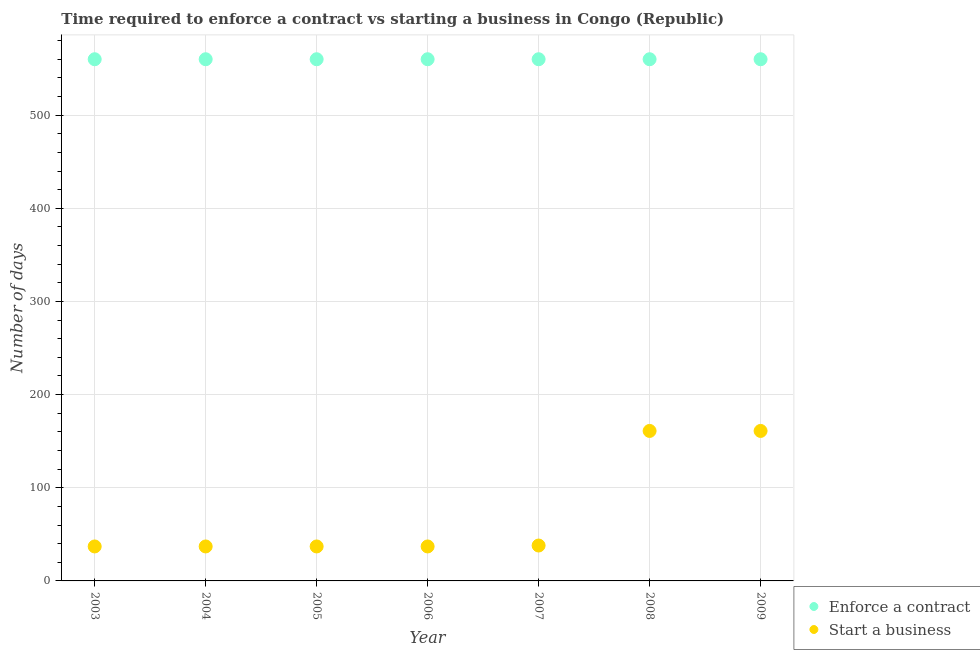What is the number of days to start a business in 2006?
Give a very brief answer. 37. Across all years, what is the maximum number of days to enforece a contract?
Provide a succinct answer. 560. Across all years, what is the minimum number of days to enforece a contract?
Provide a succinct answer. 560. In which year was the number of days to enforece a contract maximum?
Keep it short and to the point. 2003. What is the total number of days to start a business in the graph?
Offer a terse response. 508. What is the difference between the number of days to start a business in 2003 and that in 2009?
Ensure brevity in your answer.  -124. What is the difference between the number of days to enforece a contract in 2003 and the number of days to start a business in 2006?
Offer a terse response. 523. What is the average number of days to enforece a contract per year?
Provide a succinct answer. 560. In the year 2004, what is the difference between the number of days to enforece a contract and number of days to start a business?
Offer a terse response. 523. What is the ratio of the number of days to start a business in 2004 to that in 2007?
Offer a terse response. 0.97. Is the difference between the number of days to enforece a contract in 2005 and 2008 greater than the difference between the number of days to start a business in 2005 and 2008?
Give a very brief answer. Yes. What is the difference between the highest and the lowest number of days to start a business?
Provide a succinct answer. 124. How many years are there in the graph?
Your response must be concise. 7. What is the difference between two consecutive major ticks on the Y-axis?
Make the answer very short. 100. Does the graph contain any zero values?
Your response must be concise. No. Where does the legend appear in the graph?
Your answer should be very brief. Bottom right. What is the title of the graph?
Provide a succinct answer. Time required to enforce a contract vs starting a business in Congo (Republic). What is the label or title of the X-axis?
Make the answer very short. Year. What is the label or title of the Y-axis?
Provide a succinct answer. Number of days. What is the Number of days in Enforce a contract in 2003?
Provide a short and direct response. 560. What is the Number of days in Start a business in 2003?
Give a very brief answer. 37. What is the Number of days in Enforce a contract in 2004?
Keep it short and to the point. 560. What is the Number of days in Enforce a contract in 2005?
Your response must be concise. 560. What is the Number of days of Enforce a contract in 2006?
Ensure brevity in your answer.  560. What is the Number of days in Start a business in 2006?
Offer a very short reply. 37. What is the Number of days of Enforce a contract in 2007?
Your answer should be compact. 560. What is the Number of days in Start a business in 2007?
Ensure brevity in your answer.  38. What is the Number of days in Enforce a contract in 2008?
Your answer should be very brief. 560. What is the Number of days in Start a business in 2008?
Give a very brief answer. 161. What is the Number of days in Enforce a contract in 2009?
Ensure brevity in your answer.  560. What is the Number of days of Start a business in 2009?
Ensure brevity in your answer.  161. Across all years, what is the maximum Number of days in Enforce a contract?
Keep it short and to the point. 560. Across all years, what is the maximum Number of days of Start a business?
Offer a very short reply. 161. Across all years, what is the minimum Number of days of Enforce a contract?
Your answer should be compact. 560. What is the total Number of days in Enforce a contract in the graph?
Offer a terse response. 3920. What is the total Number of days of Start a business in the graph?
Offer a terse response. 508. What is the difference between the Number of days of Enforce a contract in 2003 and that in 2004?
Offer a terse response. 0. What is the difference between the Number of days in Start a business in 2003 and that in 2005?
Give a very brief answer. 0. What is the difference between the Number of days of Enforce a contract in 2003 and that in 2006?
Ensure brevity in your answer.  0. What is the difference between the Number of days in Enforce a contract in 2003 and that in 2007?
Your answer should be very brief. 0. What is the difference between the Number of days of Start a business in 2003 and that in 2007?
Your response must be concise. -1. What is the difference between the Number of days in Start a business in 2003 and that in 2008?
Provide a short and direct response. -124. What is the difference between the Number of days in Enforce a contract in 2003 and that in 2009?
Offer a terse response. 0. What is the difference between the Number of days in Start a business in 2003 and that in 2009?
Keep it short and to the point. -124. What is the difference between the Number of days of Enforce a contract in 2004 and that in 2005?
Offer a very short reply. 0. What is the difference between the Number of days in Enforce a contract in 2004 and that in 2006?
Give a very brief answer. 0. What is the difference between the Number of days in Start a business in 2004 and that in 2006?
Keep it short and to the point. 0. What is the difference between the Number of days in Start a business in 2004 and that in 2007?
Your response must be concise. -1. What is the difference between the Number of days of Enforce a contract in 2004 and that in 2008?
Your response must be concise. 0. What is the difference between the Number of days in Start a business in 2004 and that in 2008?
Keep it short and to the point. -124. What is the difference between the Number of days of Enforce a contract in 2004 and that in 2009?
Provide a succinct answer. 0. What is the difference between the Number of days of Start a business in 2004 and that in 2009?
Your response must be concise. -124. What is the difference between the Number of days of Enforce a contract in 2005 and that in 2006?
Ensure brevity in your answer.  0. What is the difference between the Number of days of Start a business in 2005 and that in 2006?
Provide a succinct answer. 0. What is the difference between the Number of days of Enforce a contract in 2005 and that in 2007?
Give a very brief answer. 0. What is the difference between the Number of days in Start a business in 2005 and that in 2007?
Ensure brevity in your answer.  -1. What is the difference between the Number of days in Start a business in 2005 and that in 2008?
Keep it short and to the point. -124. What is the difference between the Number of days in Enforce a contract in 2005 and that in 2009?
Offer a terse response. 0. What is the difference between the Number of days in Start a business in 2005 and that in 2009?
Provide a succinct answer. -124. What is the difference between the Number of days in Start a business in 2006 and that in 2008?
Keep it short and to the point. -124. What is the difference between the Number of days of Start a business in 2006 and that in 2009?
Provide a short and direct response. -124. What is the difference between the Number of days of Enforce a contract in 2007 and that in 2008?
Make the answer very short. 0. What is the difference between the Number of days of Start a business in 2007 and that in 2008?
Your answer should be compact. -123. What is the difference between the Number of days of Start a business in 2007 and that in 2009?
Give a very brief answer. -123. What is the difference between the Number of days in Enforce a contract in 2008 and that in 2009?
Make the answer very short. 0. What is the difference between the Number of days of Start a business in 2008 and that in 2009?
Your answer should be very brief. 0. What is the difference between the Number of days in Enforce a contract in 2003 and the Number of days in Start a business in 2004?
Make the answer very short. 523. What is the difference between the Number of days in Enforce a contract in 2003 and the Number of days in Start a business in 2005?
Make the answer very short. 523. What is the difference between the Number of days of Enforce a contract in 2003 and the Number of days of Start a business in 2006?
Your answer should be compact. 523. What is the difference between the Number of days in Enforce a contract in 2003 and the Number of days in Start a business in 2007?
Your answer should be very brief. 522. What is the difference between the Number of days of Enforce a contract in 2003 and the Number of days of Start a business in 2008?
Your answer should be very brief. 399. What is the difference between the Number of days of Enforce a contract in 2003 and the Number of days of Start a business in 2009?
Your answer should be compact. 399. What is the difference between the Number of days of Enforce a contract in 2004 and the Number of days of Start a business in 2005?
Offer a terse response. 523. What is the difference between the Number of days in Enforce a contract in 2004 and the Number of days in Start a business in 2006?
Give a very brief answer. 523. What is the difference between the Number of days of Enforce a contract in 2004 and the Number of days of Start a business in 2007?
Provide a succinct answer. 522. What is the difference between the Number of days in Enforce a contract in 2004 and the Number of days in Start a business in 2008?
Your answer should be compact. 399. What is the difference between the Number of days of Enforce a contract in 2004 and the Number of days of Start a business in 2009?
Ensure brevity in your answer.  399. What is the difference between the Number of days in Enforce a contract in 2005 and the Number of days in Start a business in 2006?
Keep it short and to the point. 523. What is the difference between the Number of days of Enforce a contract in 2005 and the Number of days of Start a business in 2007?
Give a very brief answer. 522. What is the difference between the Number of days in Enforce a contract in 2005 and the Number of days in Start a business in 2008?
Ensure brevity in your answer.  399. What is the difference between the Number of days of Enforce a contract in 2005 and the Number of days of Start a business in 2009?
Your response must be concise. 399. What is the difference between the Number of days of Enforce a contract in 2006 and the Number of days of Start a business in 2007?
Provide a short and direct response. 522. What is the difference between the Number of days of Enforce a contract in 2006 and the Number of days of Start a business in 2008?
Your response must be concise. 399. What is the difference between the Number of days in Enforce a contract in 2006 and the Number of days in Start a business in 2009?
Your answer should be compact. 399. What is the difference between the Number of days in Enforce a contract in 2007 and the Number of days in Start a business in 2008?
Your response must be concise. 399. What is the difference between the Number of days in Enforce a contract in 2007 and the Number of days in Start a business in 2009?
Your response must be concise. 399. What is the difference between the Number of days of Enforce a contract in 2008 and the Number of days of Start a business in 2009?
Provide a short and direct response. 399. What is the average Number of days of Enforce a contract per year?
Offer a terse response. 560. What is the average Number of days of Start a business per year?
Your response must be concise. 72.57. In the year 2003, what is the difference between the Number of days of Enforce a contract and Number of days of Start a business?
Your response must be concise. 523. In the year 2004, what is the difference between the Number of days of Enforce a contract and Number of days of Start a business?
Offer a terse response. 523. In the year 2005, what is the difference between the Number of days of Enforce a contract and Number of days of Start a business?
Give a very brief answer. 523. In the year 2006, what is the difference between the Number of days in Enforce a contract and Number of days in Start a business?
Your response must be concise. 523. In the year 2007, what is the difference between the Number of days in Enforce a contract and Number of days in Start a business?
Offer a terse response. 522. In the year 2008, what is the difference between the Number of days of Enforce a contract and Number of days of Start a business?
Your response must be concise. 399. In the year 2009, what is the difference between the Number of days of Enforce a contract and Number of days of Start a business?
Your answer should be compact. 399. What is the ratio of the Number of days of Start a business in 2003 to that in 2004?
Offer a very short reply. 1. What is the ratio of the Number of days in Enforce a contract in 2003 to that in 2005?
Provide a short and direct response. 1. What is the ratio of the Number of days in Start a business in 2003 to that in 2006?
Your response must be concise. 1. What is the ratio of the Number of days in Start a business in 2003 to that in 2007?
Keep it short and to the point. 0.97. What is the ratio of the Number of days of Enforce a contract in 2003 to that in 2008?
Your answer should be very brief. 1. What is the ratio of the Number of days of Start a business in 2003 to that in 2008?
Your response must be concise. 0.23. What is the ratio of the Number of days in Start a business in 2003 to that in 2009?
Ensure brevity in your answer.  0.23. What is the ratio of the Number of days of Enforce a contract in 2004 to that in 2005?
Make the answer very short. 1. What is the ratio of the Number of days of Start a business in 2004 to that in 2005?
Ensure brevity in your answer.  1. What is the ratio of the Number of days of Enforce a contract in 2004 to that in 2006?
Your answer should be very brief. 1. What is the ratio of the Number of days in Start a business in 2004 to that in 2006?
Offer a very short reply. 1. What is the ratio of the Number of days of Enforce a contract in 2004 to that in 2007?
Keep it short and to the point. 1. What is the ratio of the Number of days of Start a business in 2004 to that in 2007?
Ensure brevity in your answer.  0.97. What is the ratio of the Number of days in Enforce a contract in 2004 to that in 2008?
Provide a succinct answer. 1. What is the ratio of the Number of days of Start a business in 2004 to that in 2008?
Provide a short and direct response. 0.23. What is the ratio of the Number of days in Enforce a contract in 2004 to that in 2009?
Your answer should be compact. 1. What is the ratio of the Number of days in Start a business in 2004 to that in 2009?
Offer a terse response. 0.23. What is the ratio of the Number of days in Start a business in 2005 to that in 2007?
Your answer should be very brief. 0.97. What is the ratio of the Number of days of Start a business in 2005 to that in 2008?
Offer a very short reply. 0.23. What is the ratio of the Number of days of Enforce a contract in 2005 to that in 2009?
Keep it short and to the point. 1. What is the ratio of the Number of days in Start a business in 2005 to that in 2009?
Offer a very short reply. 0.23. What is the ratio of the Number of days in Start a business in 2006 to that in 2007?
Your answer should be compact. 0.97. What is the ratio of the Number of days of Start a business in 2006 to that in 2008?
Your answer should be very brief. 0.23. What is the ratio of the Number of days in Start a business in 2006 to that in 2009?
Offer a terse response. 0.23. What is the ratio of the Number of days in Enforce a contract in 2007 to that in 2008?
Provide a short and direct response. 1. What is the ratio of the Number of days of Start a business in 2007 to that in 2008?
Offer a very short reply. 0.24. What is the ratio of the Number of days of Start a business in 2007 to that in 2009?
Your answer should be very brief. 0.24. What is the ratio of the Number of days in Start a business in 2008 to that in 2009?
Keep it short and to the point. 1. What is the difference between the highest and the second highest Number of days of Start a business?
Offer a very short reply. 0. What is the difference between the highest and the lowest Number of days of Start a business?
Keep it short and to the point. 124. 